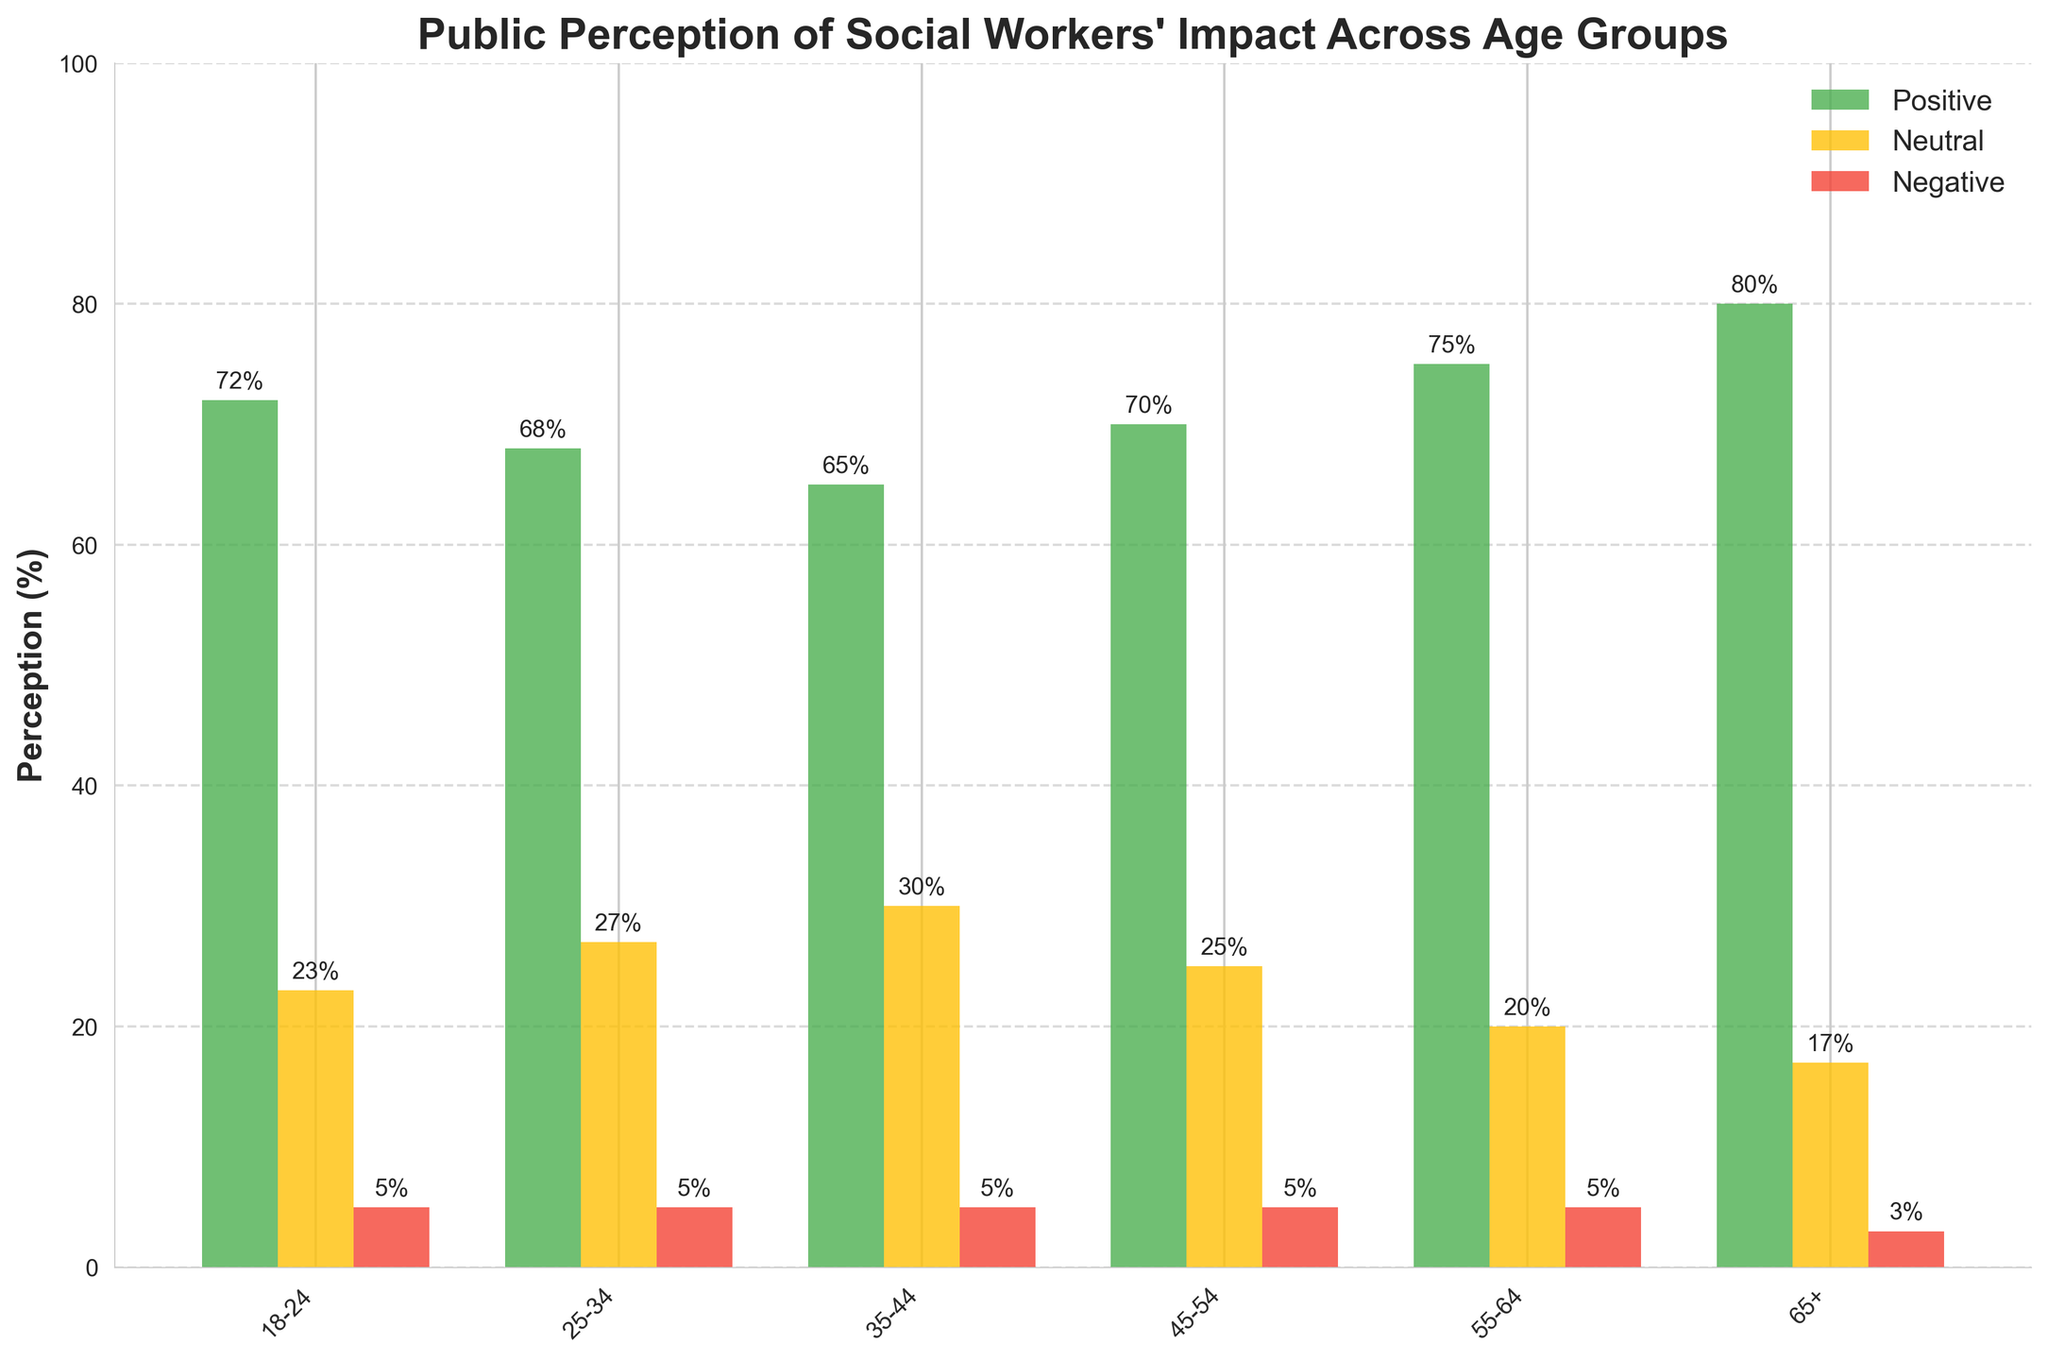Which age group has the highest positive perception of social workers' impact? The age group of 65+ has the highest bar among the bars representing positive perceptions.
Answer: 65+ How does the neutral perception of social workers compare between the 25-34 and 35-44 age groups? The neutral perception of social workers is higher in the 35-44 age group than in the 25-34 age group. This is evident by comparing the heights of the yellow bars for these age groups.
Answer: Higher in the 35-44 group Which age group has the lowest negative perception of social workers' impact? The age group of 65+ has the lowest negative perception, indicated by the shorter red bar.
Answer: 65+ What is the sum of positive and neutral perceptions for the 55-64 age group? Sum the values of positive and neutral perceptions for the 55-64 age group: 75% + 20% = 95%.
Answer: 95% Between which two age groups is the positive perception very similar? Compare the green bars; the positive perception is very similar between the 18-24 and 25-34 age groups, each having values of 72% and 68%, respectively.
Answer: 18-24 and 25-34 What is the range of positive perception of social workers' impact across all age groups? The difference between the highest and lowest values of positive perceptions gives the range: 80% (65+) - 65% (35-44) = 15%.
Answer: 15% How does the negative perception compare across all age groups? The negative perception for all age groups is relatively similar, generally around 5%, except for the 65+ age group, which is slightly lower at 3%.
Answer: Around 5%, with the 65+ age group at 3% Which age group has the least neutral perception of social workers' impact? The 65+ age group has the least neutral perception, indicated by the shortest yellow bar.
Answer: 65+ Calculate the average positive perception across all age groups. Add up the positive perception values and divide by the number of age groups: (72+68+65+70+75+80)/6 = 71.67%.
Answer: 71.67% Is there any age group where the neutral perception exceeds the positive perception? No, in all age groups, the positive perception (green bars) exceeds the neutral perception (yellow bars).
Answer: No 